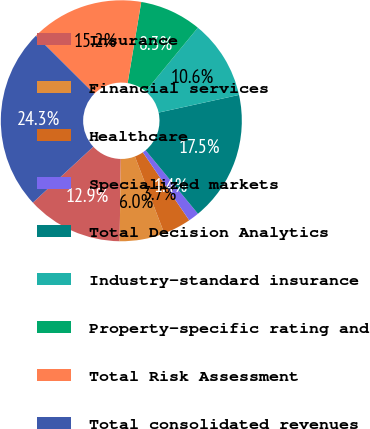<chart> <loc_0><loc_0><loc_500><loc_500><pie_chart><fcel>Insurance<fcel>Financial services<fcel>Healthcare<fcel>Specialized markets<fcel>Total Decision Analytics<fcel>Industry-standard insurance<fcel>Property-specific rating and<fcel>Total Risk Assessment<fcel>Total consolidated revenues<nl><fcel>12.89%<fcel>6.02%<fcel>3.73%<fcel>1.44%<fcel>17.47%<fcel>10.6%<fcel>8.31%<fcel>15.18%<fcel>24.34%<nl></chart> 